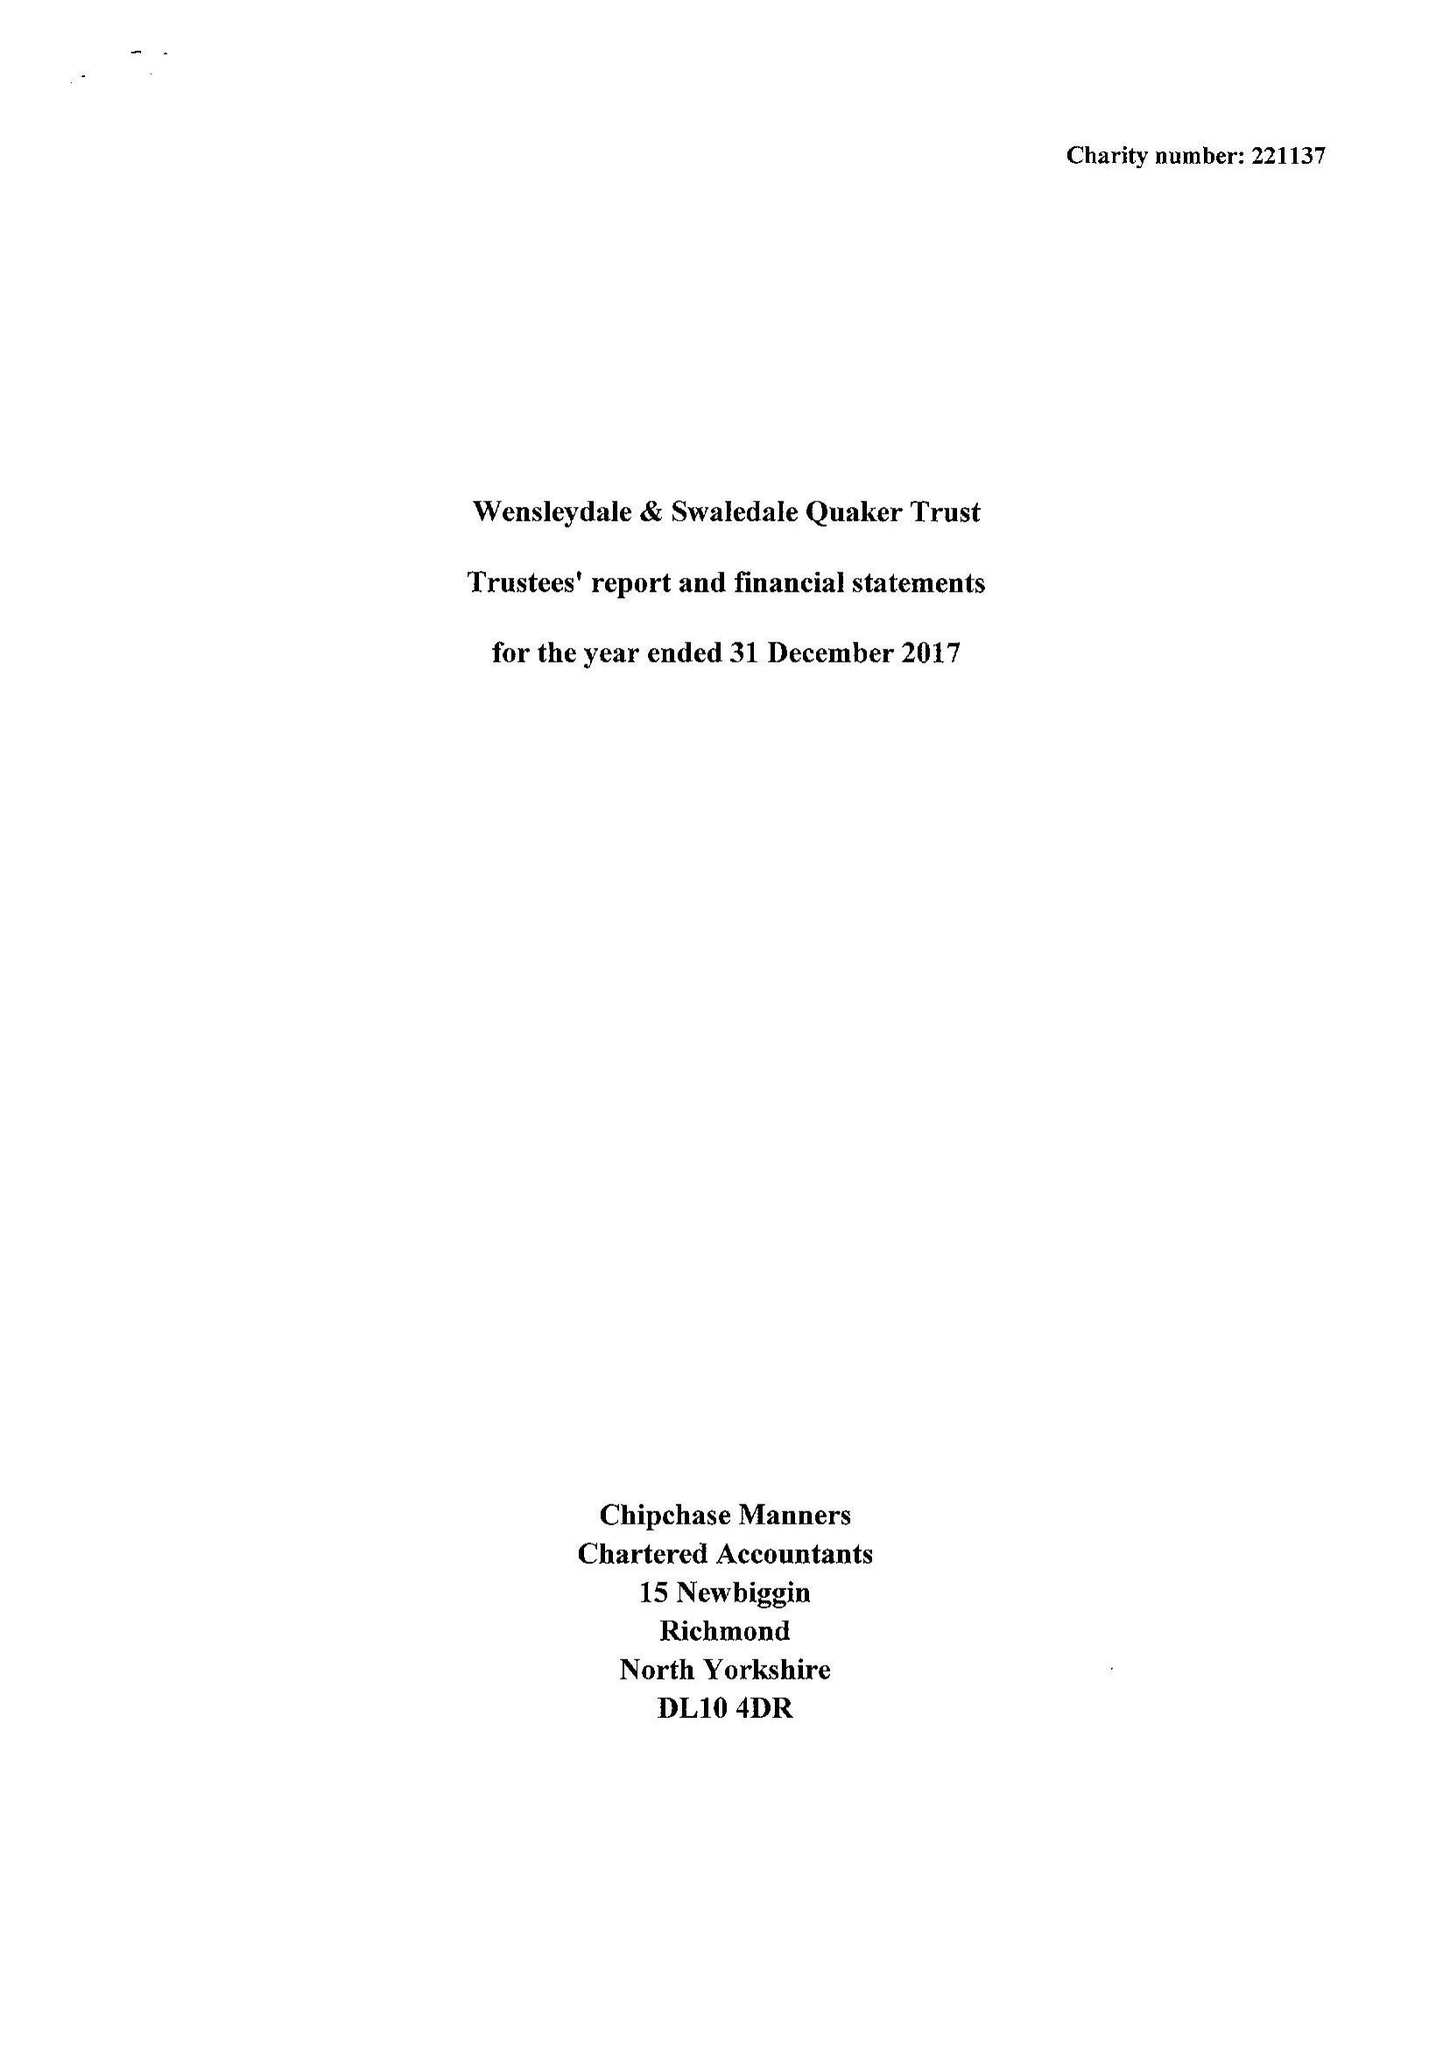What is the value for the address__post_town?
Answer the question using a single word or phrase. HAWES 